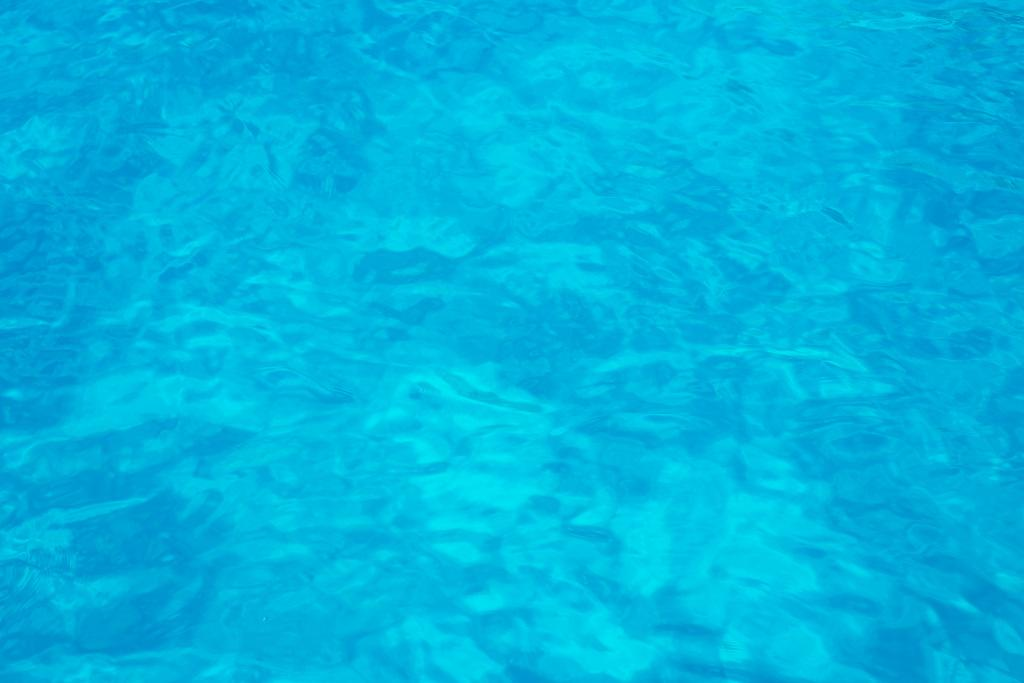What color is the surface visible in the image? The surface in the image is blue. How many farmers can be seen working in the sea in the image? There are no farmers or sea present in the image; it only features a blue surface. What type of books are placed on the blue surface in the image? There are no books present on the blue surface in the image. 